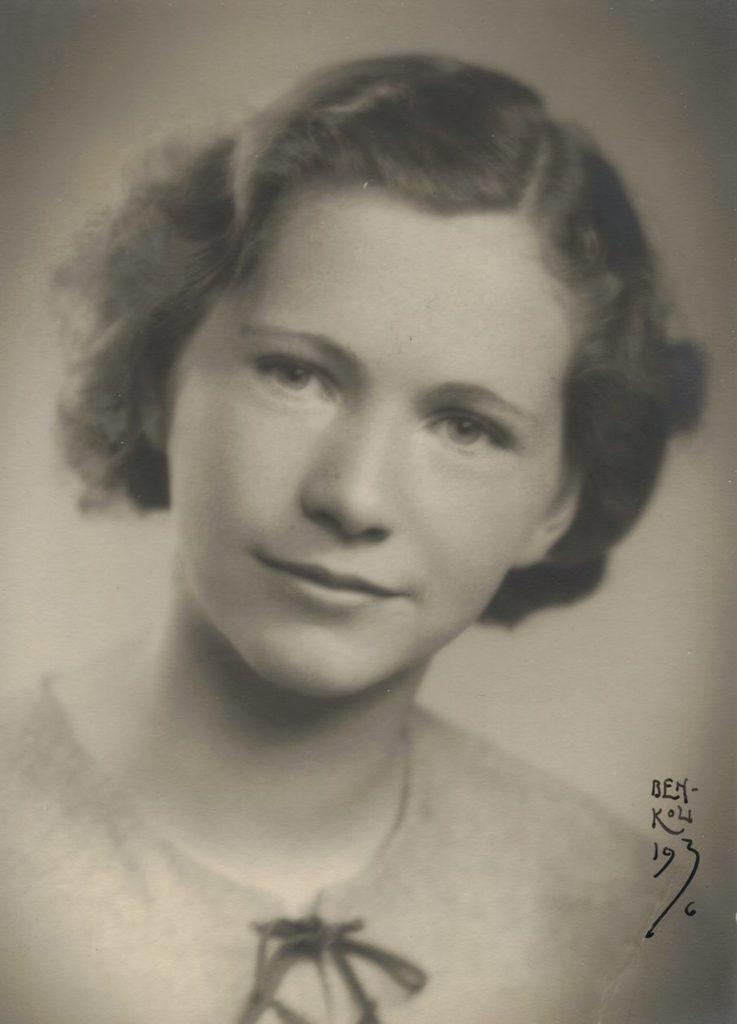In one or two sentences, can you explain what this image depicts? Picture of a woman, she is looking forward. Background it is blur. Right side of the image we can see a watermark. 